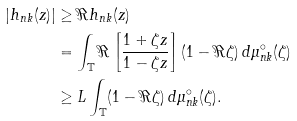Convert formula to latex. <formula><loc_0><loc_0><loc_500><loc_500>\left | h _ { n k } ( z ) \right | & \geq \Re h _ { n k } ( z ) \\ & = \int _ { \mathbb { T } } \Re \left [ \frac { 1 + \zeta z } { 1 - \zeta z } \right ] ( 1 - \Re \zeta ) \, d \mu _ { n k } ^ { \circ } ( \zeta ) \\ & \geq L \int _ { \mathbb { T } } ( 1 - \Re \zeta ) \, d \mu _ { n k } ^ { \circ } ( \zeta ) .</formula> 